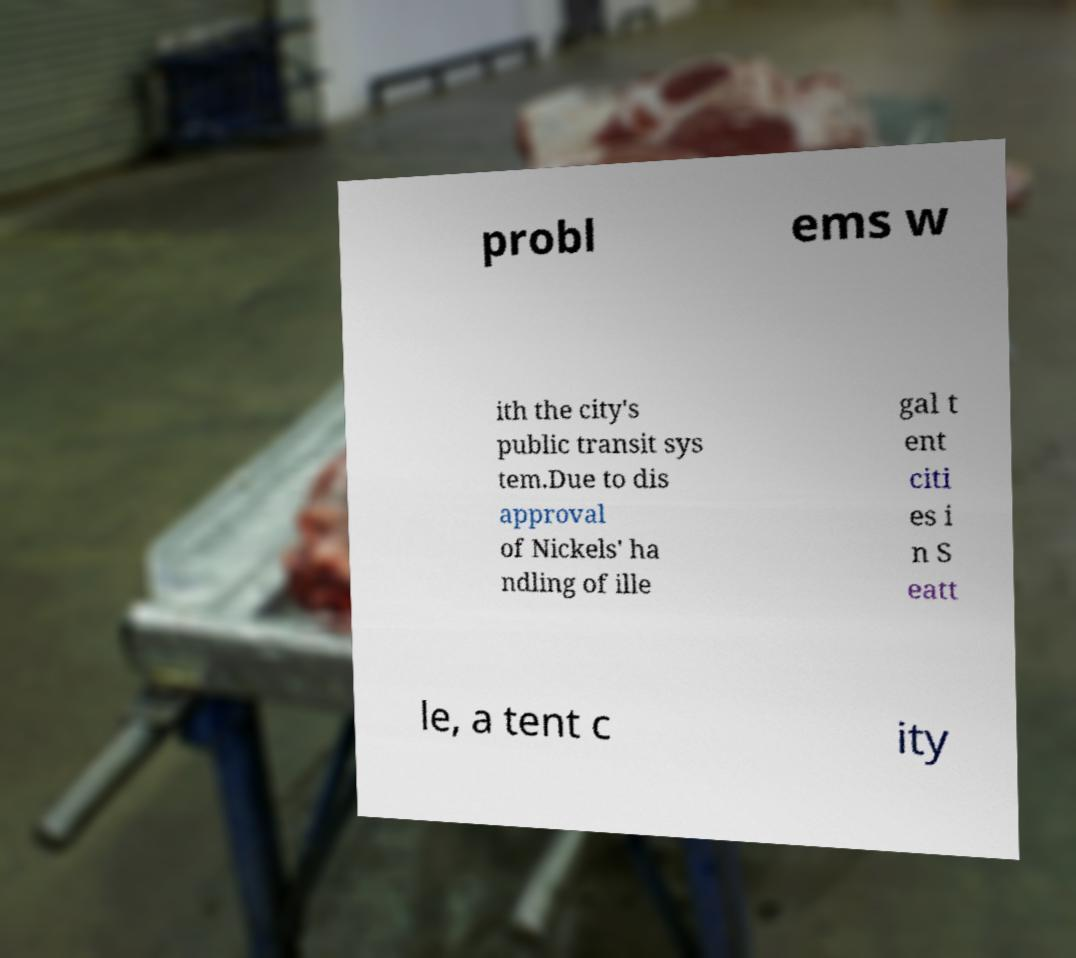Please read and relay the text visible in this image. What does it say? probl ems w ith the city's public transit sys tem.Due to dis approval of Nickels' ha ndling of ille gal t ent citi es i n S eatt le, a tent c ity 